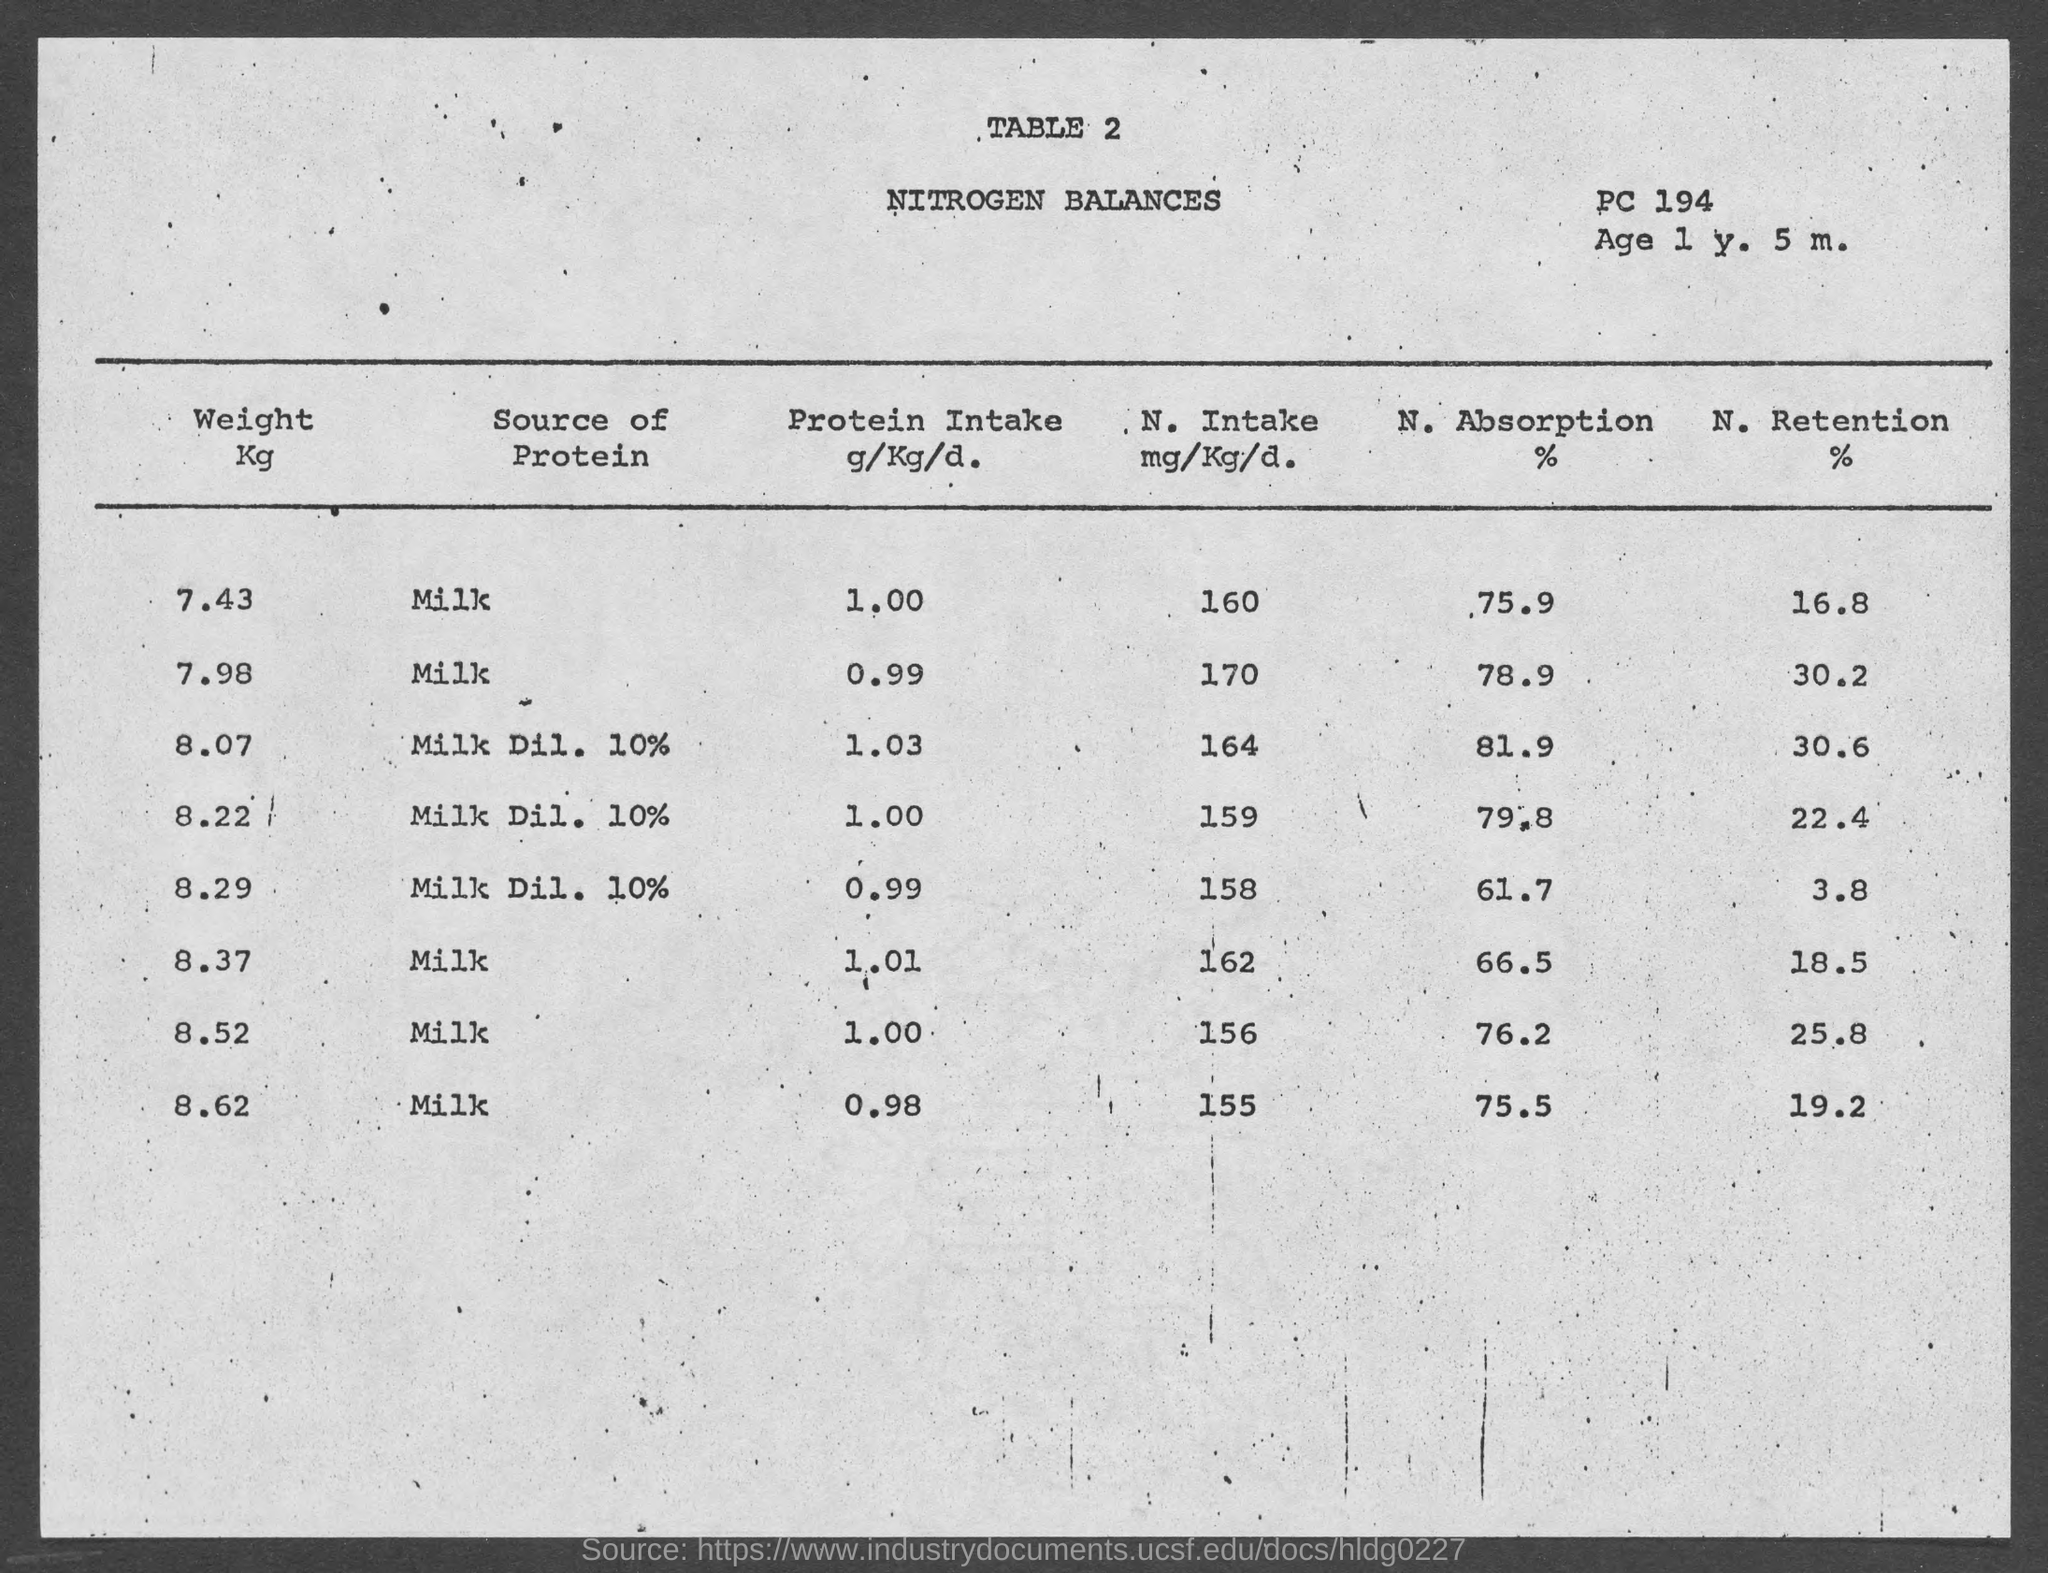Outline some significant characteristics in this image. The title of Table 2 is "Nitrogen Balances. 